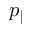<formula> <loc_0><loc_0><loc_500><loc_500>p _ { \| }</formula> 